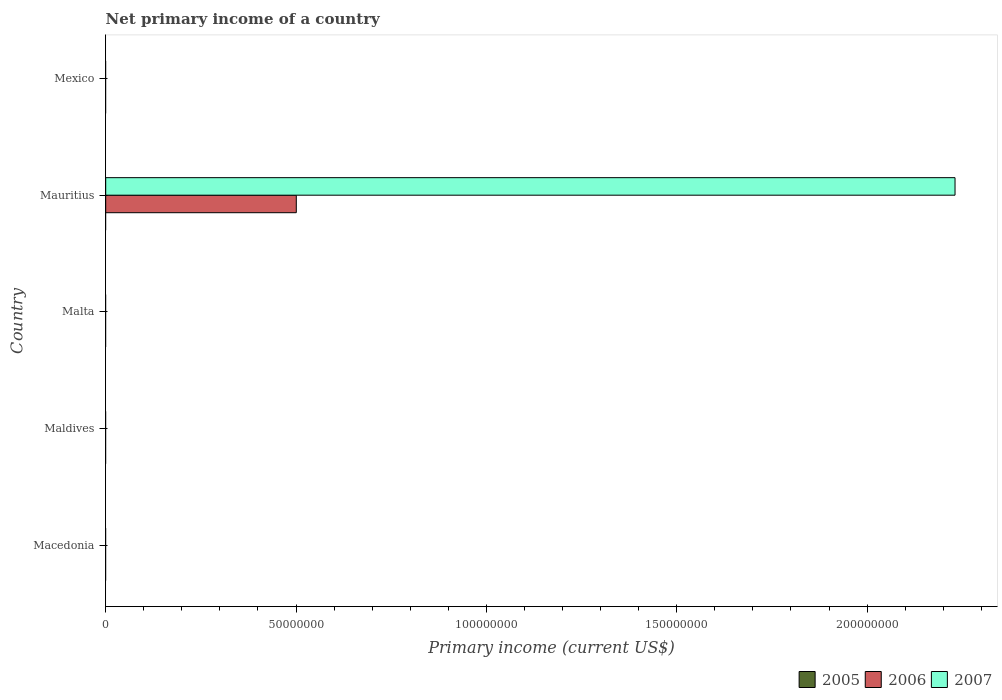How many different coloured bars are there?
Your answer should be very brief. 2. Are the number of bars per tick equal to the number of legend labels?
Make the answer very short. No. Are the number of bars on each tick of the Y-axis equal?
Provide a succinct answer. No. How many bars are there on the 5th tick from the top?
Give a very brief answer. 0. What is the label of the 4th group of bars from the top?
Your response must be concise. Maldives. In how many cases, is the number of bars for a given country not equal to the number of legend labels?
Keep it short and to the point. 5. What is the primary income in 2007 in Mauritius?
Give a very brief answer. 2.23e+08. Across all countries, what is the maximum primary income in 2006?
Your response must be concise. 5.01e+07. Across all countries, what is the minimum primary income in 2006?
Offer a terse response. 0. In which country was the primary income in 2006 maximum?
Keep it short and to the point. Mauritius. What is the total primary income in 2006 in the graph?
Provide a short and direct response. 5.01e+07. What is the difference between the primary income in 2006 in Maldives and the primary income in 2005 in Macedonia?
Make the answer very short. 0. What is the average primary income in 2007 per country?
Offer a terse response. 4.46e+07. What is the difference between the highest and the lowest primary income in 2006?
Offer a very short reply. 5.01e+07. In how many countries, is the primary income in 2006 greater than the average primary income in 2006 taken over all countries?
Provide a short and direct response. 1. How many bars are there?
Offer a terse response. 2. Are all the bars in the graph horizontal?
Your answer should be very brief. Yes. What is the difference between two consecutive major ticks on the X-axis?
Offer a terse response. 5.00e+07. Are the values on the major ticks of X-axis written in scientific E-notation?
Offer a very short reply. No. Does the graph contain any zero values?
Your response must be concise. Yes. Does the graph contain grids?
Provide a succinct answer. No. How many legend labels are there?
Provide a short and direct response. 3. What is the title of the graph?
Keep it short and to the point. Net primary income of a country. What is the label or title of the X-axis?
Offer a very short reply. Primary income (current US$). What is the label or title of the Y-axis?
Provide a short and direct response. Country. What is the Primary income (current US$) in 2005 in Macedonia?
Make the answer very short. 0. What is the Primary income (current US$) in 2006 in Macedonia?
Offer a terse response. 0. What is the Primary income (current US$) in 2006 in Maldives?
Provide a succinct answer. 0. What is the Primary income (current US$) of 2005 in Malta?
Your answer should be very brief. 0. What is the Primary income (current US$) in 2006 in Malta?
Provide a short and direct response. 0. What is the Primary income (current US$) in 2005 in Mauritius?
Your answer should be compact. 0. What is the Primary income (current US$) of 2006 in Mauritius?
Offer a very short reply. 5.01e+07. What is the Primary income (current US$) of 2007 in Mauritius?
Your answer should be very brief. 2.23e+08. What is the Primary income (current US$) in 2005 in Mexico?
Keep it short and to the point. 0. What is the Primary income (current US$) of 2006 in Mexico?
Give a very brief answer. 0. Across all countries, what is the maximum Primary income (current US$) of 2006?
Ensure brevity in your answer.  5.01e+07. Across all countries, what is the maximum Primary income (current US$) of 2007?
Your answer should be very brief. 2.23e+08. Across all countries, what is the minimum Primary income (current US$) in 2006?
Your response must be concise. 0. Across all countries, what is the minimum Primary income (current US$) in 2007?
Your answer should be compact. 0. What is the total Primary income (current US$) of 2005 in the graph?
Ensure brevity in your answer.  0. What is the total Primary income (current US$) in 2006 in the graph?
Offer a terse response. 5.01e+07. What is the total Primary income (current US$) in 2007 in the graph?
Your answer should be very brief. 2.23e+08. What is the average Primary income (current US$) in 2005 per country?
Offer a very short reply. 0. What is the average Primary income (current US$) in 2006 per country?
Ensure brevity in your answer.  1.00e+07. What is the average Primary income (current US$) of 2007 per country?
Your answer should be compact. 4.46e+07. What is the difference between the Primary income (current US$) in 2006 and Primary income (current US$) in 2007 in Mauritius?
Make the answer very short. -1.73e+08. What is the difference between the highest and the lowest Primary income (current US$) of 2006?
Give a very brief answer. 5.01e+07. What is the difference between the highest and the lowest Primary income (current US$) in 2007?
Keep it short and to the point. 2.23e+08. 